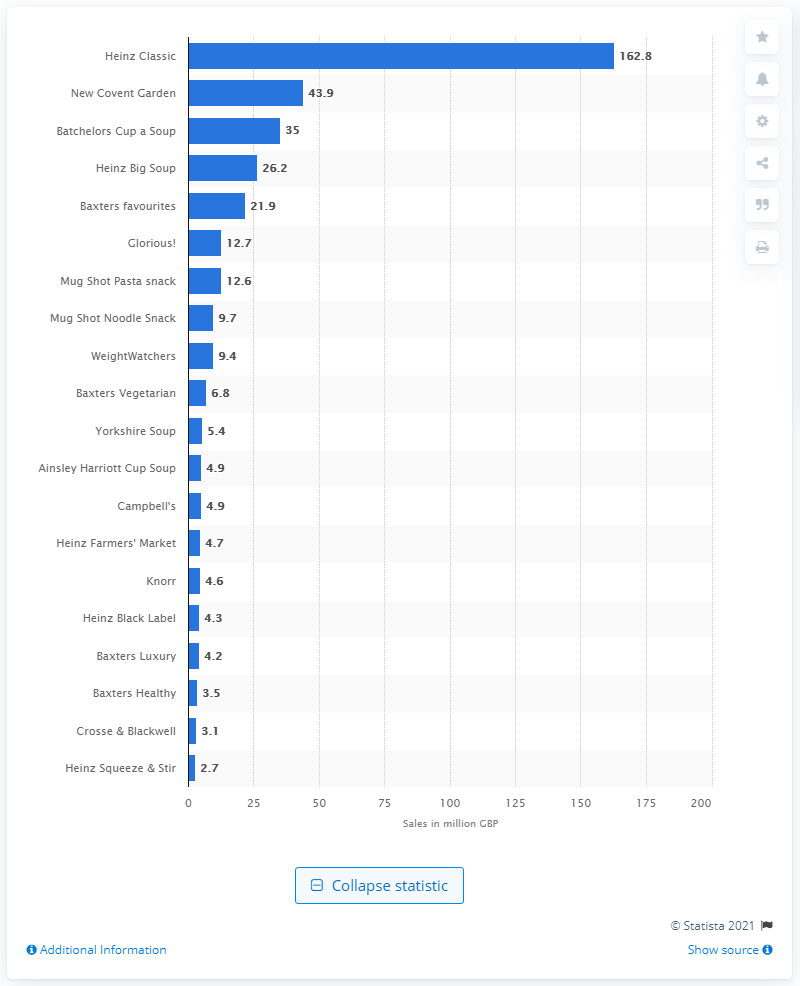Indicate a few pertinent items in this graphic. The total sales value of Heinz Classic was 162.8 million dollars. 